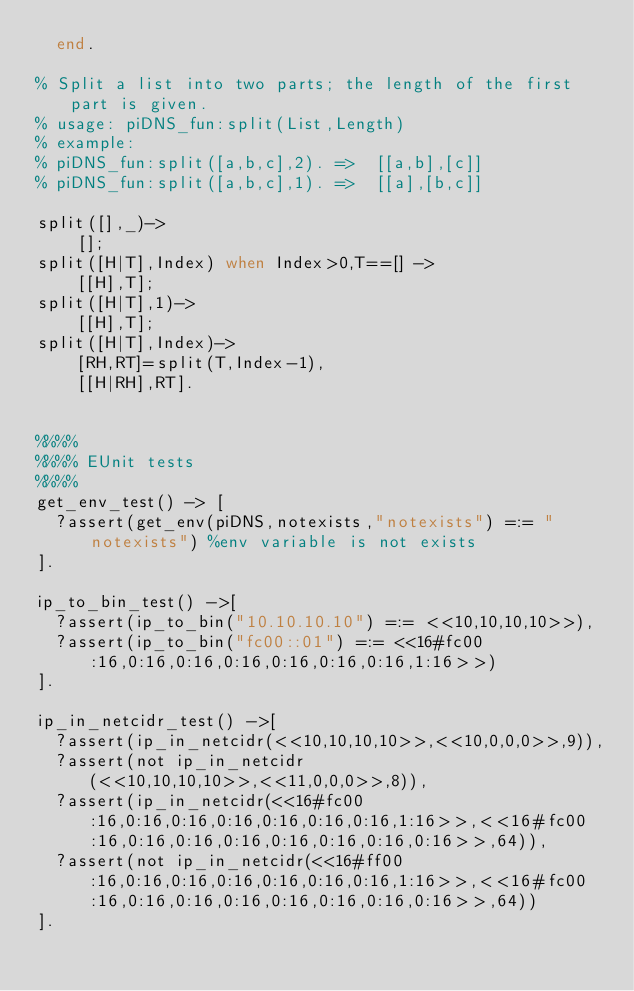<code> <loc_0><loc_0><loc_500><loc_500><_Erlang_>	end.

% Split a list into two parts; the length of the first part is given.
% usage: piDNS_fun:split(List,Length)
% example:
% piDNS_fun:split([a,b,c],2). =>  [[a,b],[c]]
% piDNS_fun:split([a,b,c],1). =>  [[a],[b,c]]

split([],_)->
    [];
split([H|T],Index) when Index>0,T==[] ->
    [[H],T];
split([H|T],1)->
    [[H],T];
split([H|T],Index)->
    [RH,RT]=split(T,Index-1),
    [[H|RH],RT].


%%%%
%%%% EUnit tests
%%%%
get_env_test() -> [
	?assert(get_env(piDNS,notexists,"notexists") =:= "notexists") %env variable is not exists
].

ip_to_bin_test() ->[
	?assert(ip_to_bin("10.10.10.10") =:= <<10,10,10,10>>),
	?assert(ip_to_bin("fc00::01") =:= <<16#fc00:16,0:16,0:16,0:16,0:16,0:16,0:16,1:16>>)
].

ip_in_netcidr_test() ->[
	?assert(ip_in_netcidr(<<10,10,10,10>>,<<10,0,0,0>>,9)),
	?assert(not ip_in_netcidr(<<10,10,10,10>>,<<11,0,0,0>>,8)),
	?assert(ip_in_netcidr(<<16#fc00:16,0:16,0:16,0:16,0:16,0:16,0:16,1:16>>,<<16#fc00:16,0:16,0:16,0:16,0:16,0:16,0:16,0:16>>,64)),
	?assert(not ip_in_netcidr(<<16#ff00:16,0:16,0:16,0:16,0:16,0:16,0:16,1:16>>,<<16#fc00:16,0:16,0:16,0:16,0:16,0:16,0:16,0:16>>,64))
].</code> 